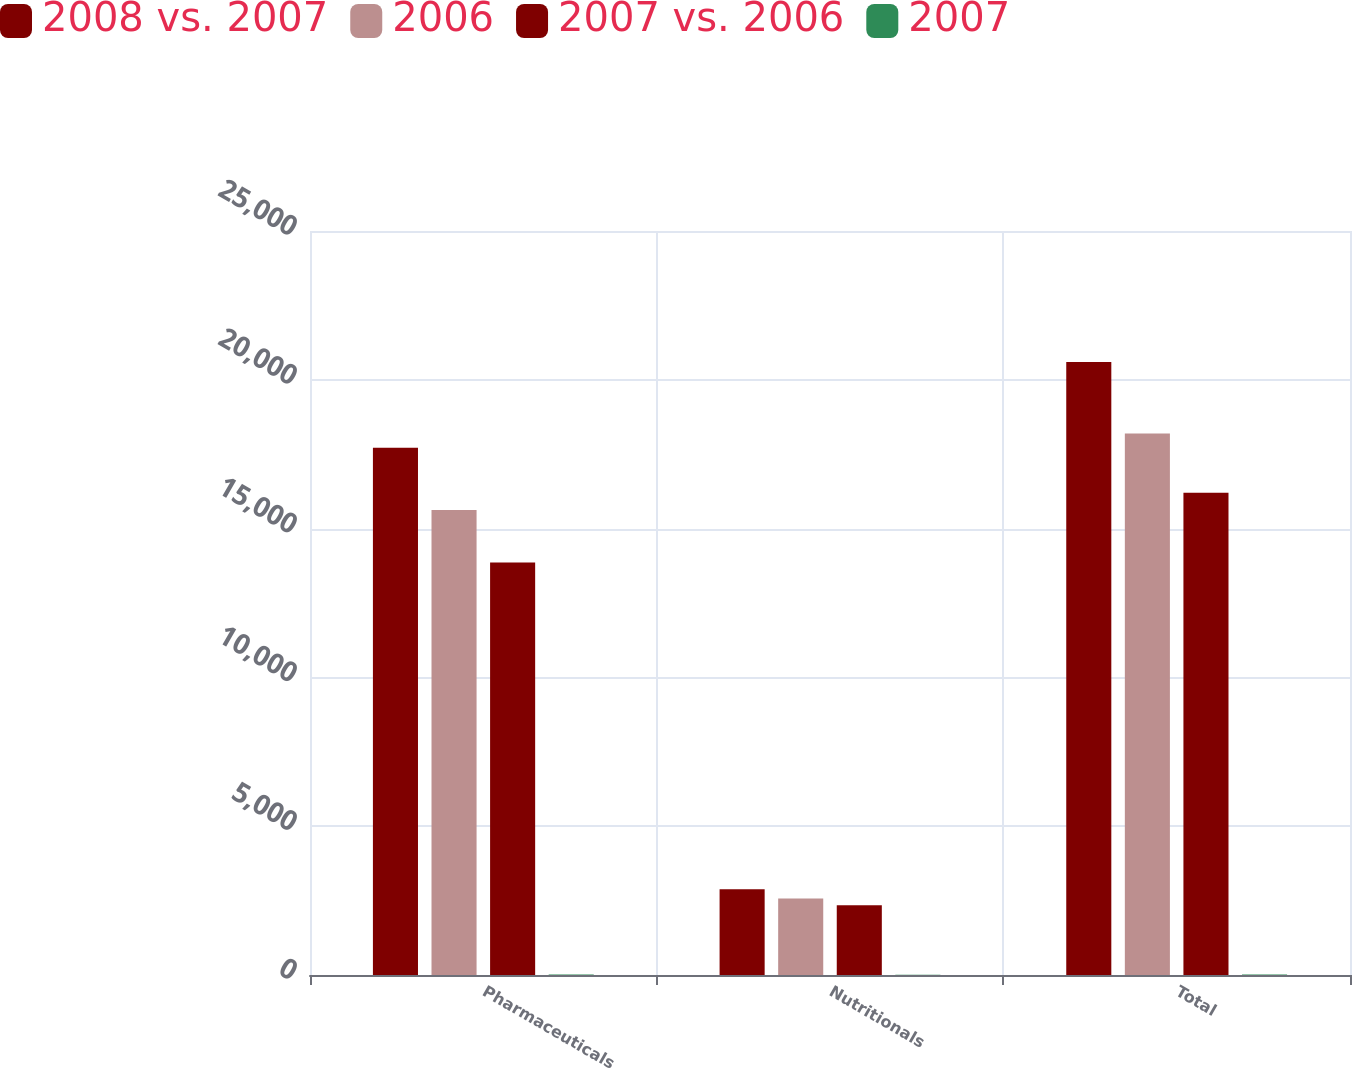Convert chart to OTSL. <chart><loc_0><loc_0><loc_500><loc_500><stacked_bar_chart><ecel><fcel>Pharmaceuticals<fcel>Nutritionals<fcel>Total<nl><fcel>2008 vs. 2007<fcel>17715<fcel>2882<fcel>20597<nl><fcel>2006<fcel>15622<fcel>2571<fcel>18193<nl><fcel>2007 vs. 2006<fcel>13861<fcel>2347<fcel>16208<nl><fcel>2007<fcel>13<fcel>12<fcel>13<nl></chart> 